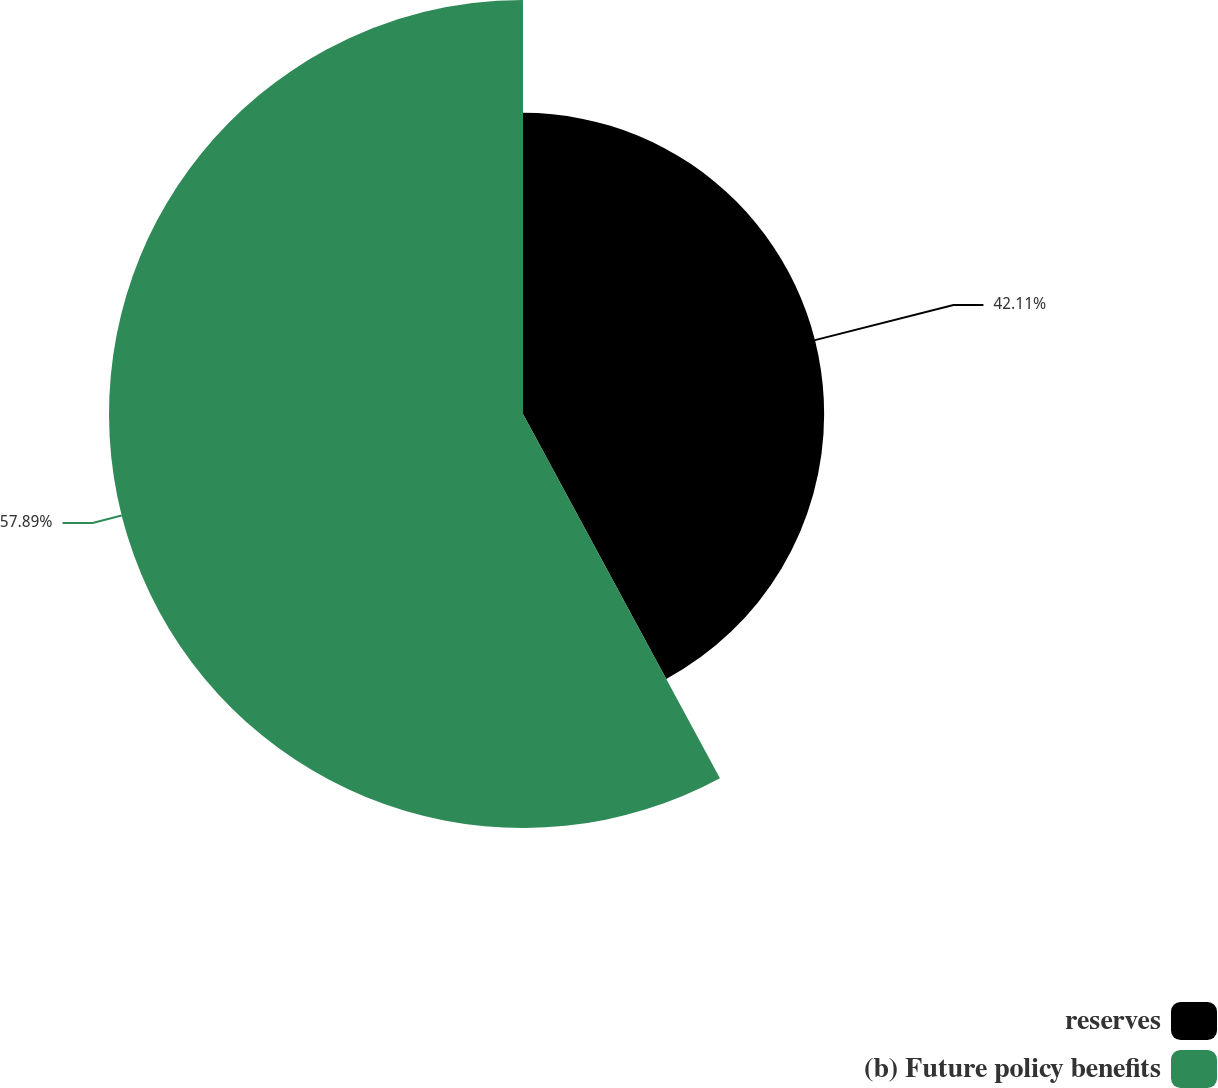Convert chart. <chart><loc_0><loc_0><loc_500><loc_500><pie_chart><fcel>reserves<fcel>(b) Future policy benefits<nl><fcel>42.11%<fcel>57.89%<nl></chart> 